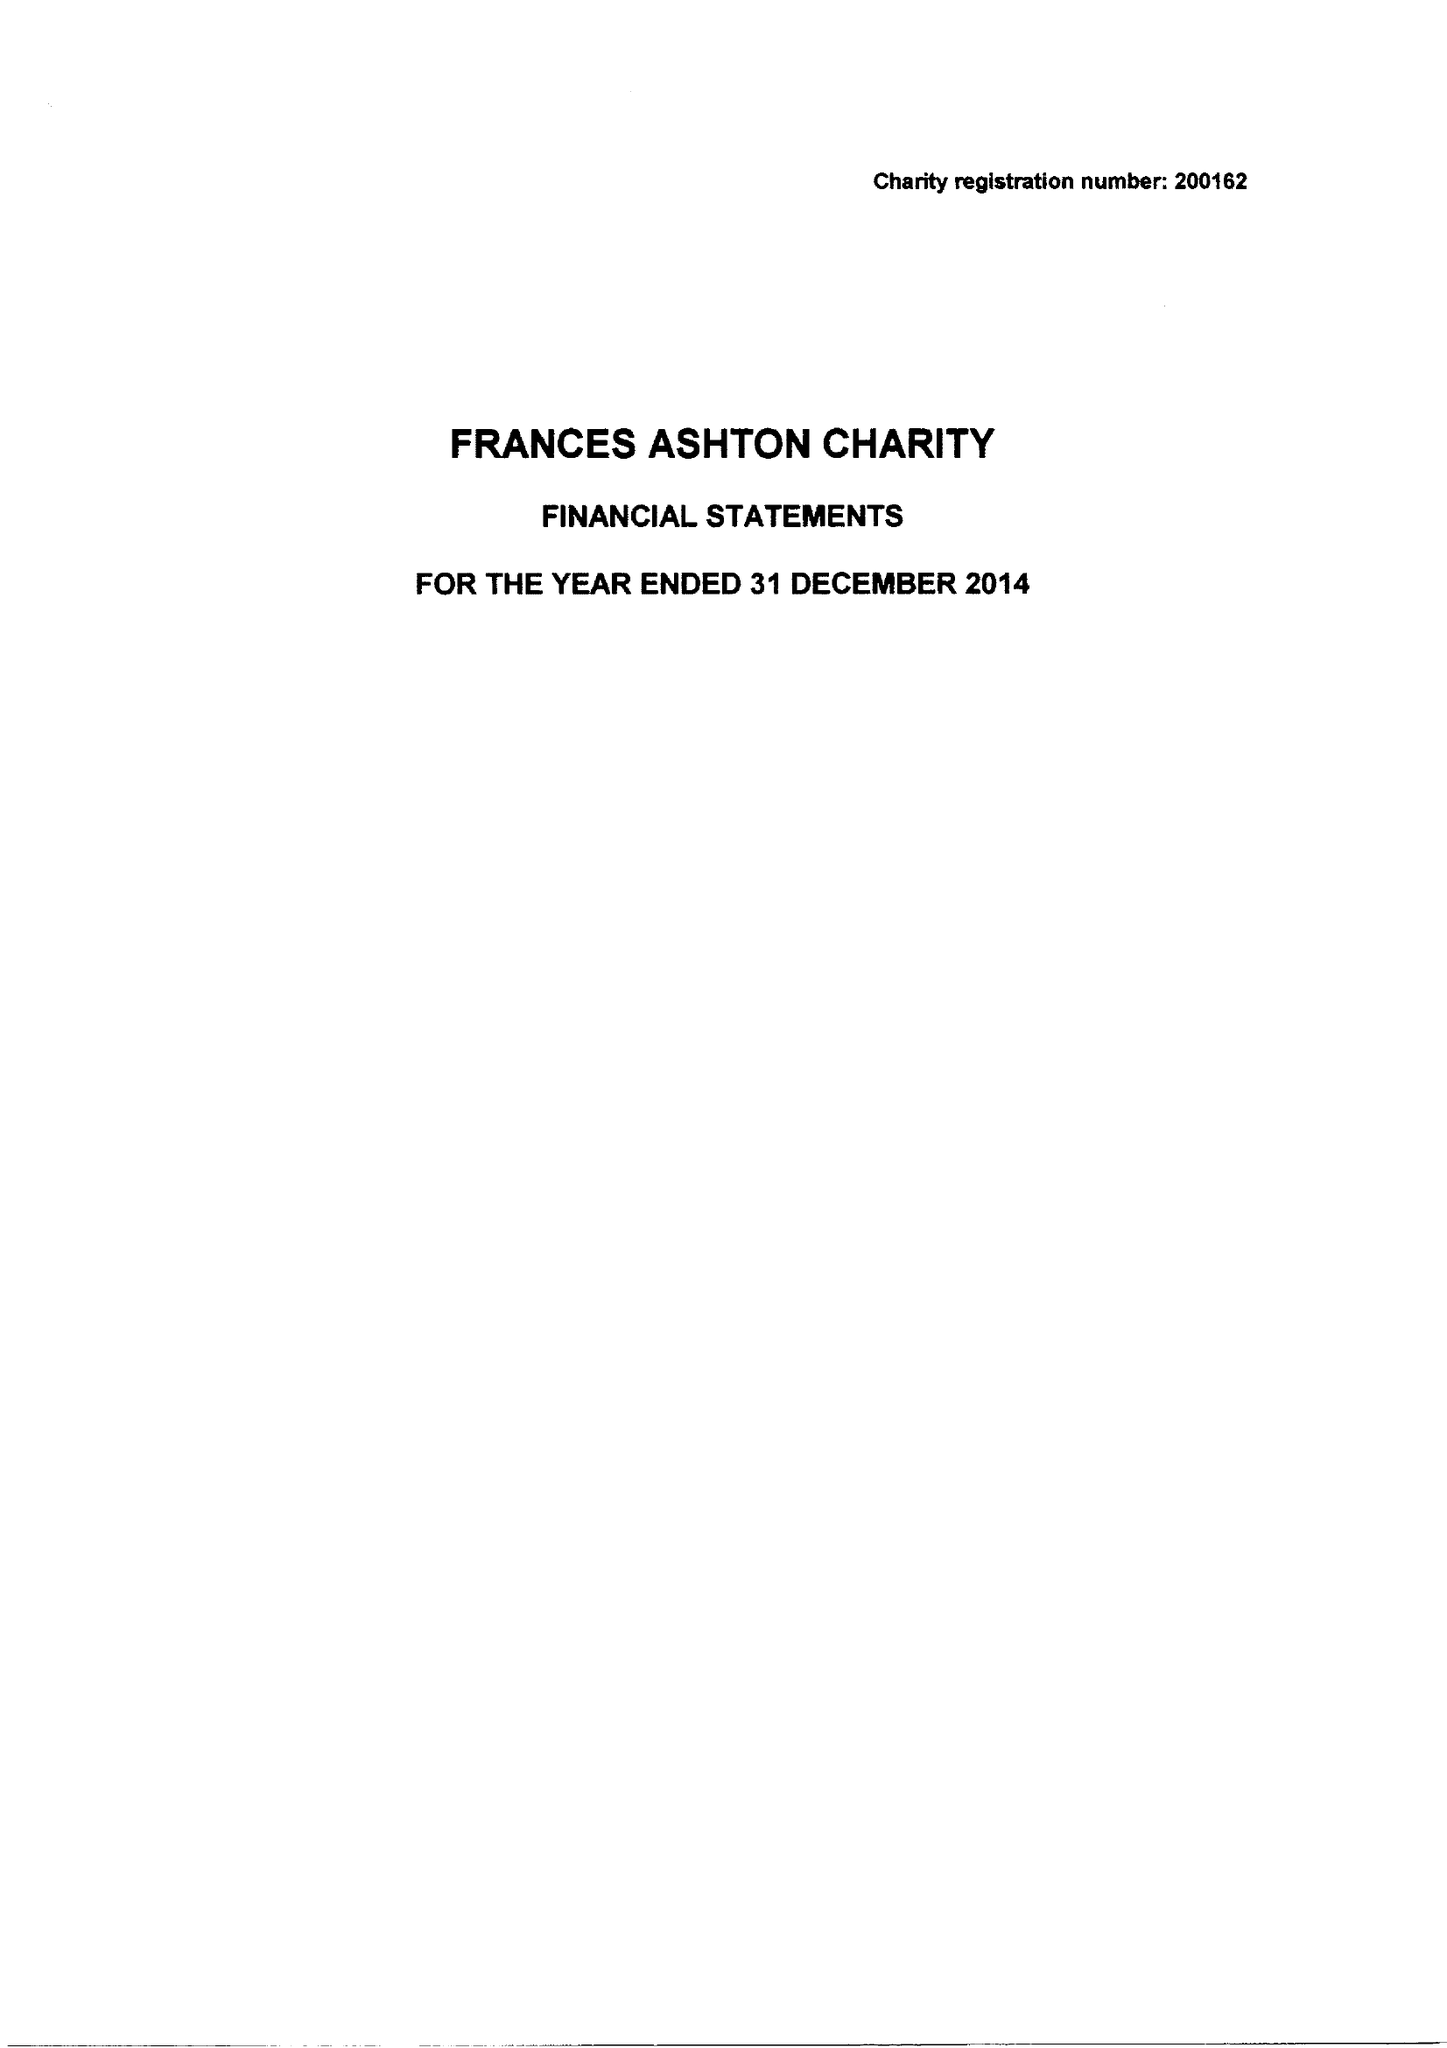What is the value for the income_annually_in_british_pounds?
Answer the question using a single word or phrase. 74672.00 